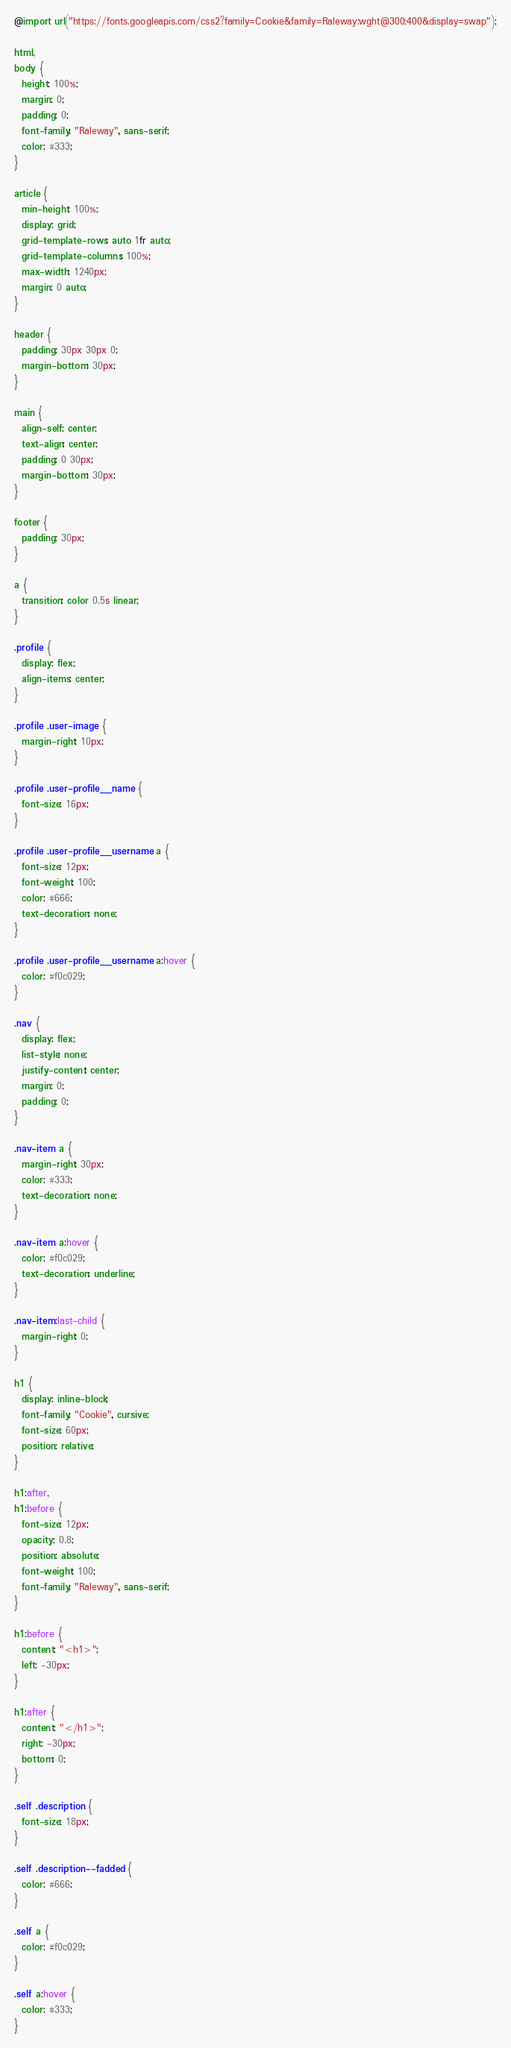<code> <loc_0><loc_0><loc_500><loc_500><_CSS_>@import url("https://fonts.googleapis.com/css2?family=Cookie&family=Raleway:wght@300;400&display=swap");

html,
body {
  height: 100%;
  margin: 0;
  padding: 0;
  font-family: "Raleway", sans-serif;
  color: #333;
}

article {
  min-height: 100%;
  display: grid;
  grid-template-rows: auto 1fr auto;
  grid-template-columns: 100%;
  max-width: 1240px;
  margin: 0 auto;
}

header {
  padding: 30px 30px 0;
  margin-bottom: 30px;
}

main {
  align-self: center;
  text-align: center;
  padding: 0 30px;
  margin-bottom: 30px;
}

footer {
  padding: 30px;
}

a {
  transition: color 0.5s linear;
}

.profile {
  display: flex;
  align-items: center;
}

.profile .user-image {
  margin-right: 10px;
}

.profile .user-profile__name {
  font-size: 16px;
}

.profile .user-profile__username a {
  font-size: 12px;
  font-weight: 100;
  color: #666;
  text-decoration: none;
}

.profile .user-profile__username a:hover {
  color: #f0c029;
}

.nav {
  display: flex;
  list-style: none;
  justify-content: center;
  margin: 0;
  padding: 0;
}

.nav-item a {
  margin-right: 30px;
  color: #333;
  text-decoration: none;
}

.nav-item a:hover {
  color: #f0c029;
  text-decoration: underline;
}

.nav-item:last-child {
  margin-right: 0;
}

h1 {
  display: inline-block;
  font-family: "Cookie", cursive;
  font-size: 60px;
  position: relative;
}

h1:after,
h1:before {
  font-size: 12px;
  opacity: 0.8;
  position: absolute;
  font-weight: 100;
  font-family: "Raleway", sans-serif;
}

h1:before {
  content: "<h1>";
  left: -30px;
}

h1:after {
  content: "</h1>";
  right: -30px;
  bottom: 0;
}

.self .description {
  font-size: 18px;
}

.self .description--fadded {
  color: #666;
}

.self a {
  color: #f0c029;
}

.self a:hover {
  color: #333;
}
</code> 